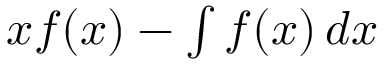Convert formula to latex. <formula><loc_0><loc_0><loc_500><loc_500>x f ( x ) - \int f ( x ) \, d x</formula> 